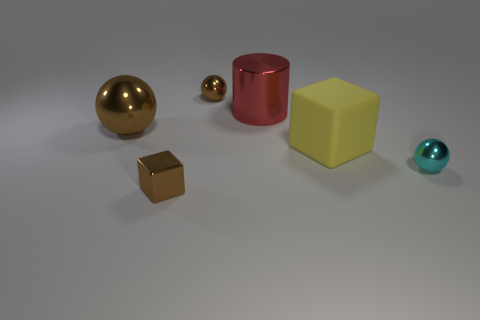Subtract 1 spheres. How many spheres are left? 2 Add 3 brown metallic objects. How many objects exist? 9 Subtract all blocks. How many objects are left? 4 Subtract all cyan shiny spheres. Subtract all red cylinders. How many objects are left? 4 Add 5 yellow matte objects. How many yellow matte objects are left? 6 Add 4 tiny red objects. How many tiny red objects exist? 4 Subtract 0 green spheres. How many objects are left? 6 